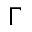<formula> <loc_0><loc_0><loc_500><loc_500>\Gamma</formula> 